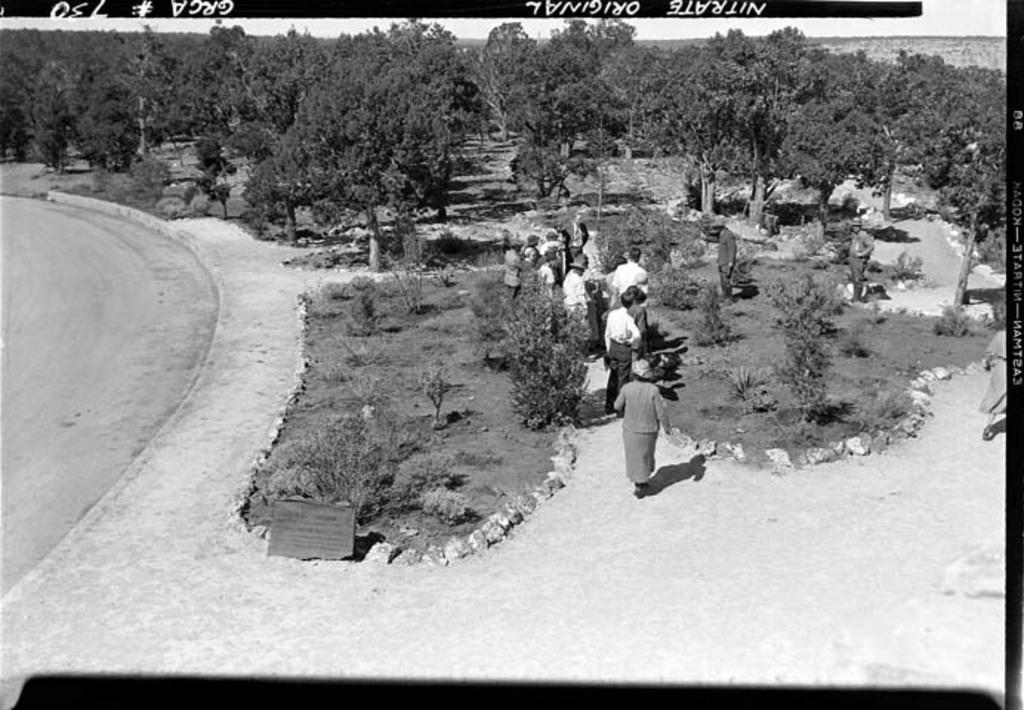Please provide a concise description of this image. In this image we can see a black and white picture of a group of people standing on the ground. In the background, we can see a group of trees and the sky. 